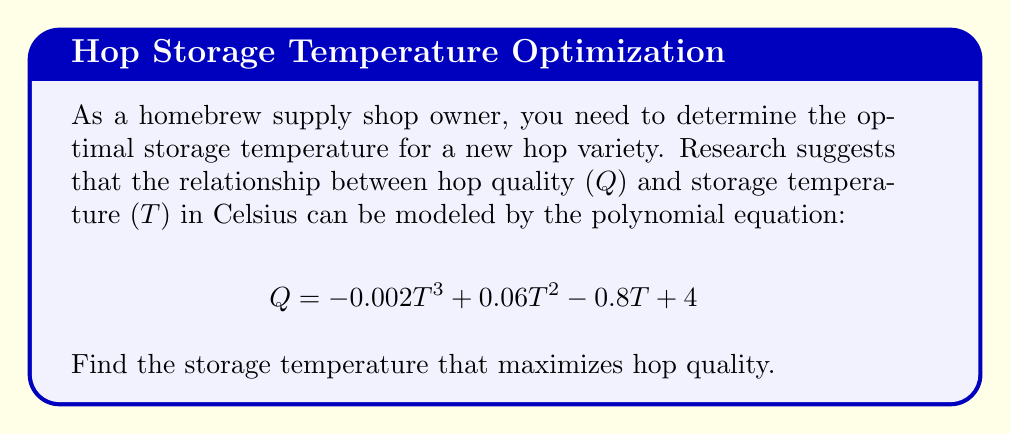Show me your answer to this math problem. To find the temperature that maximizes hop quality, we need to find the maximum point of the given polynomial function. This can be done by following these steps:

1. Find the derivative of the function:
   $$ \frac{dQ}{dT} = -0.006T^2 + 0.12T - 0.8 $$

2. Set the derivative equal to zero to find critical points:
   $$ -0.006T^2 + 0.12T - 0.8 = 0 $$

3. Solve the quadratic equation:
   $$ -0.006(T^2 - 20T + 133.33) = 0 $$
   $$ (T - 10)^2 - 33.33 = 0 $$
   $$ (T - 10)^2 = 33.33 $$
   $$ T - 10 = \pm \sqrt{33.33} $$
   $$ T = 10 \pm 5.77 $$

4. This gives us two critical points: $T_1 \approx 4.23$ and $T_2 \approx 15.77$

5. To determine which point is the maximum, we can use the second derivative test:
   $$ \frac{d^2Q}{dT^2} = -0.012T + 0.12 $$

6. Evaluate the second derivative at $T_1$ and $T_2$:
   At $T_1 = 4.23$: $\frac{d^2Q}{dT^2} = 0.069 > 0$ (local minimum)
   At $T_2 = 15.77$: $\frac{d^2Q}{dT^2} = -0.069 < 0$ (local maximum)

Therefore, the hop quality is maximized at $T \approx 15.77°C$.
Answer: The optimal storage temperature for maximizing hop quality is approximately 15.77°C (or about 60.4°F). 